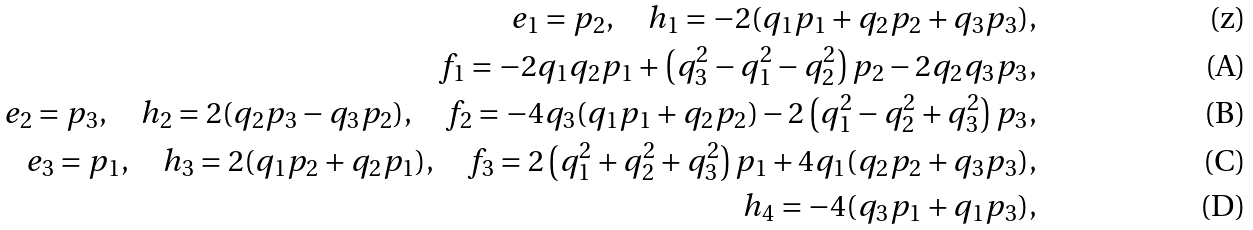Convert formula to latex. <formula><loc_0><loc_0><loc_500><loc_500>e _ { 1 } = p _ { 2 } , \quad h _ { 1 } = - 2 ( q _ { 1 } p _ { 1 } + q _ { 2 } p _ { 2 } + q _ { 3 } p _ { 3 } ) , \\ f _ { 1 } = - 2 q _ { 1 } q _ { 2 } p _ { 1 } + \left ( q _ { 3 } ^ { 2 } - q _ { 1 } ^ { 2 } - q _ { 2 } ^ { 2 } \right ) p _ { 2 } - 2 q _ { 2 } q _ { 3 } p _ { 3 } , \\ e _ { 2 } = p _ { 3 } , \quad h _ { 2 } = 2 ( q _ { 2 } p _ { 3 } - q _ { 3 } p _ { 2 } ) , \quad f _ { 2 } = - 4 q _ { 3 } ( q _ { 1 } p _ { 1 } + q _ { 2 } p _ { 2 } ) - 2 \left ( q _ { 1 } ^ { 2 } - q _ { 2 } ^ { 2 } + q _ { 3 } ^ { 2 } \right ) p _ { 3 } , \\ e _ { 3 } = p _ { 1 } , \quad h _ { 3 } = 2 ( q _ { 1 } p _ { 2 } + q _ { 2 } p _ { 1 } ) , \quad f _ { 3 } = 2 \left ( q _ { 1 } ^ { 2 } + q _ { 2 } ^ { 2 } + q _ { 3 } ^ { 2 } \right ) p _ { 1 } + 4 q _ { 1 } ( q _ { 2 } p _ { 2 } + q _ { 3 } p _ { 3 } ) , \\ h _ { 4 } = - 4 ( q _ { 3 } p _ { 1 } + q _ { 1 } p _ { 3 } ) ,</formula> 